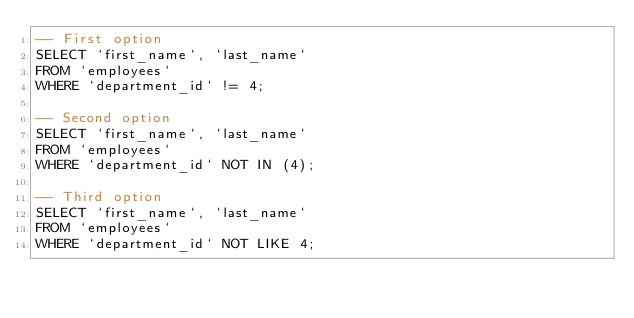Convert code to text. <code><loc_0><loc_0><loc_500><loc_500><_SQL_>-- First option
SELECT `first_name`, `last_name`
FROM `employees`
WHERE `department_id` != 4;

-- Second option
SELECT `first_name`, `last_name`
FROM `employees`
WHERE `department_id` NOT IN (4);

-- Third option
SELECT `first_name`, `last_name`
FROM `employees`
WHERE `department_id` NOT LIKE 4;
</code> 